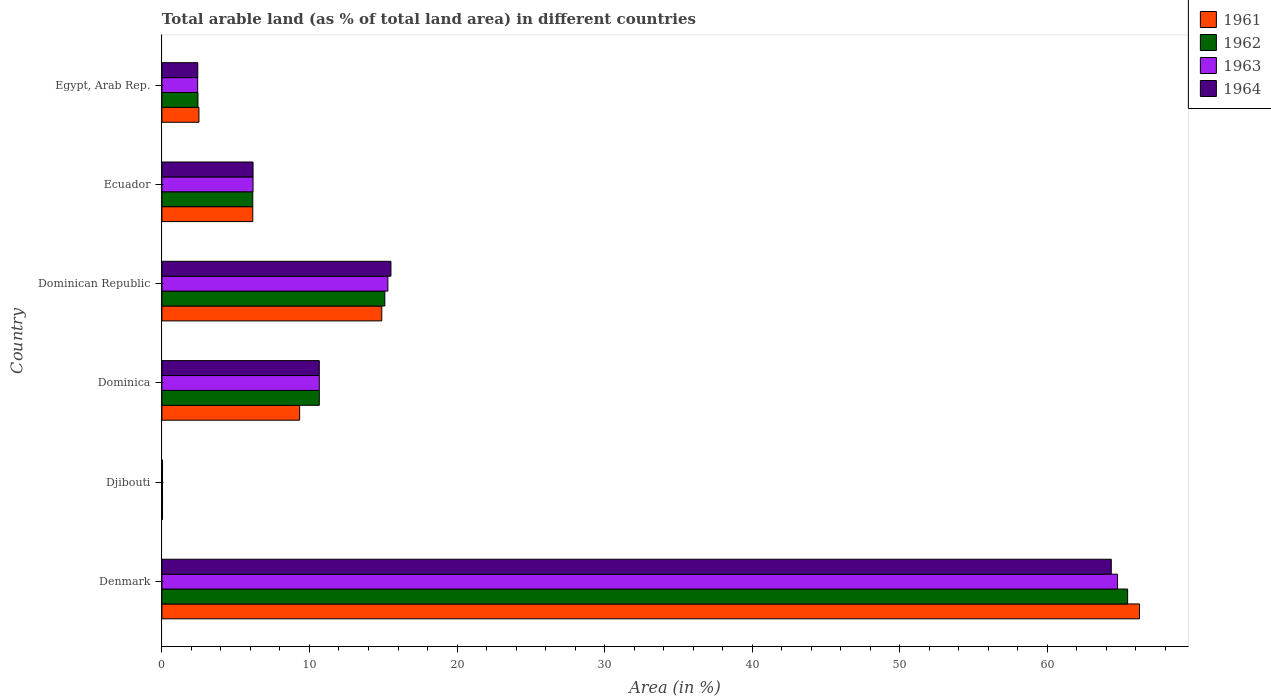How many bars are there on the 2nd tick from the bottom?
Your answer should be compact. 4. What is the label of the 2nd group of bars from the top?
Provide a succinct answer. Ecuador. In how many cases, is the number of bars for a given country not equal to the number of legend labels?
Keep it short and to the point. 0. What is the percentage of arable land in 1963 in Djibouti?
Ensure brevity in your answer.  0.04. Across all countries, what is the maximum percentage of arable land in 1961?
Give a very brief answer. 66.25. Across all countries, what is the minimum percentage of arable land in 1964?
Your answer should be very brief. 0.04. In which country was the percentage of arable land in 1961 minimum?
Your answer should be very brief. Djibouti. What is the total percentage of arable land in 1961 in the graph?
Provide a succinct answer. 99.2. What is the difference between the percentage of arable land in 1964 in Dominican Republic and that in Egypt, Arab Rep.?
Provide a short and direct response. 13.09. What is the difference between the percentage of arable land in 1964 in Dominica and the percentage of arable land in 1963 in Djibouti?
Keep it short and to the point. 10.62. What is the average percentage of arable land in 1964 per country?
Your response must be concise. 16.53. What is the difference between the percentage of arable land in 1962 and percentage of arable land in 1964 in Denmark?
Make the answer very short. 1.11. What is the ratio of the percentage of arable land in 1964 in Dominica to that in Dominican Republic?
Make the answer very short. 0.69. Is the percentage of arable land in 1962 in Djibouti less than that in Egypt, Arab Rep.?
Keep it short and to the point. Yes. What is the difference between the highest and the second highest percentage of arable land in 1962?
Ensure brevity in your answer.  50.34. What is the difference between the highest and the lowest percentage of arable land in 1963?
Keep it short and to the point. 64.72. In how many countries, is the percentage of arable land in 1961 greater than the average percentage of arable land in 1961 taken over all countries?
Provide a succinct answer. 1. Is the sum of the percentage of arable land in 1964 in Dominica and Egypt, Arab Rep. greater than the maximum percentage of arable land in 1961 across all countries?
Your response must be concise. No. What does the 3rd bar from the top in Egypt, Arab Rep. represents?
Provide a succinct answer. 1962. What does the 2nd bar from the bottom in Egypt, Arab Rep. represents?
Provide a short and direct response. 1962. How many countries are there in the graph?
Keep it short and to the point. 6. Are the values on the major ticks of X-axis written in scientific E-notation?
Provide a short and direct response. No. Does the graph contain any zero values?
Your answer should be very brief. No. Does the graph contain grids?
Provide a short and direct response. No. How many legend labels are there?
Offer a terse response. 4. What is the title of the graph?
Your answer should be compact. Total arable land (as % of total land area) in different countries. What is the label or title of the X-axis?
Keep it short and to the point. Area (in %). What is the Area (in %) of 1961 in Denmark?
Your response must be concise. 66.25. What is the Area (in %) of 1962 in Denmark?
Keep it short and to the point. 65.45. What is the Area (in %) of 1963 in Denmark?
Keep it short and to the point. 64.76. What is the Area (in %) of 1964 in Denmark?
Offer a terse response. 64.34. What is the Area (in %) of 1961 in Djibouti?
Give a very brief answer. 0.04. What is the Area (in %) in 1962 in Djibouti?
Keep it short and to the point. 0.04. What is the Area (in %) in 1963 in Djibouti?
Your response must be concise. 0.04. What is the Area (in %) in 1964 in Djibouti?
Your answer should be compact. 0.04. What is the Area (in %) of 1961 in Dominica?
Keep it short and to the point. 9.33. What is the Area (in %) in 1962 in Dominica?
Ensure brevity in your answer.  10.67. What is the Area (in %) of 1963 in Dominica?
Offer a terse response. 10.67. What is the Area (in %) of 1964 in Dominica?
Provide a short and direct response. 10.67. What is the Area (in %) in 1961 in Dominican Republic?
Give a very brief answer. 14.9. What is the Area (in %) of 1962 in Dominican Republic?
Your answer should be very brief. 15.11. What is the Area (in %) in 1963 in Dominican Republic?
Offer a terse response. 15.31. What is the Area (in %) in 1964 in Dominican Republic?
Provide a short and direct response. 15.52. What is the Area (in %) of 1961 in Ecuador?
Your response must be concise. 6.16. What is the Area (in %) of 1962 in Ecuador?
Ensure brevity in your answer.  6.16. What is the Area (in %) of 1963 in Ecuador?
Your answer should be compact. 6.18. What is the Area (in %) of 1964 in Ecuador?
Make the answer very short. 6.18. What is the Area (in %) of 1961 in Egypt, Arab Rep.?
Make the answer very short. 2.51. What is the Area (in %) in 1962 in Egypt, Arab Rep.?
Your answer should be very brief. 2.44. What is the Area (in %) in 1963 in Egypt, Arab Rep.?
Ensure brevity in your answer.  2.42. What is the Area (in %) in 1964 in Egypt, Arab Rep.?
Give a very brief answer. 2.43. Across all countries, what is the maximum Area (in %) in 1961?
Offer a very short reply. 66.25. Across all countries, what is the maximum Area (in %) of 1962?
Make the answer very short. 65.45. Across all countries, what is the maximum Area (in %) in 1963?
Ensure brevity in your answer.  64.76. Across all countries, what is the maximum Area (in %) of 1964?
Make the answer very short. 64.34. Across all countries, what is the minimum Area (in %) in 1961?
Offer a terse response. 0.04. Across all countries, what is the minimum Area (in %) in 1962?
Make the answer very short. 0.04. Across all countries, what is the minimum Area (in %) in 1963?
Make the answer very short. 0.04. Across all countries, what is the minimum Area (in %) in 1964?
Ensure brevity in your answer.  0.04. What is the total Area (in %) in 1961 in the graph?
Provide a succinct answer. 99.2. What is the total Area (in %) of 1962 in the graph?
Your answer should be compact. 99.87. What is the total Area (in %) of 1963 in the graph?
Offer a terse response. 99.39. What is the total Area (in %) in 1964 in the graph?
Make the answer very short. 99.18. What is the difference between the Area (in %) in 1961 in Denmark and that in Djibouti?
Give a very brief answer. 66.21. What is the difference between the Area (in %) of 1962 in Denmark and that in Djibouti?
Your answer should be very brief. 65.4. What is the difference between the Area (in %) of 1963 in Denmark and that in Djibouti?
Make the answer very short. 64.72. What is the difference between the Area (in %) of 1964 in Denmark and that in Djibouti?
Make the answer very short. 64.29. What is the difference between the Area (in %) of 1961 in Denmark and that in Dominica?
Provide a succinct answer. 56.92. What is the difference between the Area (in %) in 1962 in Denmark and that in Dominica?
Your answer should be compact. 54.78. What is the difference between the Area (in %) in 1963 in Denmark and that in Dominica?
Give a very brief answer. 54.1. What is the difference between the Area (in %) in 1964 in Denmark and that in Dominica?
Provide a succinct answer. 53.67. What is the difference between the Area (in %) of 1961 in Denmark and that in Dominican Republic?
Your answer should be compact. 51.35. What is the difference between the Area (in %) of 1962 in Denmark and that in Dominican Republic?
Make the answer very short. 50.34. What is the difference between the Area (in %) in 1963 in Denmark and that in Dominican Republic?
Offer a very short reply. 49.45. What is the difference between the Area (in %) of 1964 in Denmark and that in Dominican Republic?
Your answer should be very brief. 48.82. What is the difference between the Area (in %) in 1961 in Denmark and that in Ecuador?
Your response must be concise. 60.09. What is the difference between the Area (in %) of 1962 in Denmark and that in Ecuador?
Make the answer very short. 59.29. What is the difference between the Area (in %) of 1963 in Denmark and that in Ecuador?
Your answer should be very brief. 58.59. What is the difference between the Area (in %) of 1964 in Denmark and that in Ecuador?
Give a very brief answer. 58.16. What is the difference between the Area (in %) of 1961 in Denmark and that in Egypt, Arab Rep.?
Your response must be concise. 63.74. What is the difference between the Area (in %) of 1962 in Denmark and that in Egypt, Arab Rep.?
Provide a short and direct response. 63. What is the difference between the Area (in %) of 1963 in Denmark and that in Egypt, Arab Rep.?
Give a very brief answer. 62.34. What is the difference between the Area (in %) in 1964 in Denmark and that in Egypt, Arab Rep.?
Offer a terse response. 61.9. What is the difference between the Area (in %) of 1961 in Djibouti and that in Dominica?
Your response must be concise. -9.29. What is the difference between the Area (in %) of 1962 in Djibouti and that in Dominica?
Keep it short and to the point. -10.62. What is the difference between the Area (in %) in 1963 in Djibouti and that in Dominica?
Provide a short and direct response. -10.62. What is the difference between the Area (in %) of 1964 in Djibouti and that in Dominica?
Provide a succinct answer. -10.62. What is the difference between the Area (in %) of 1961 in Djibouti and that in Dominican Republic?
Ensure brevity in your answer.  -14.86. What is the difference between the Area (in %) in 1962 in Djibouti and that in Dominican Republic?
Keep it short and to the point. -15.06. What is the difference between the Area (in %) in 1963 in Djibouti and that in Dominican Republic?
Your answer should be very brief. -15.27. What is the difference between the Area (in %) in 1964 in Djibouti and that in Dominican Republic?
Provide a short and direct response. -15.48. What is the difference between the Area (in %) in 1961 in Djibouti and that in Ecuador?
Your answer should be very brief. -6.12. What is the difference between the Area (in %) of 1962 in Djibouti and that in Ecuador?
Ensure brevity in your answer.  -6.12. What is the difference between the Area (in %) of 1963 in Djibouti and that in Ecuador?
Provide a short and direct response. -6.13. What is the difference between the Area (in %) of 1964 in Djibouti and that in Ecuador?
Keep it short and to the point. -6.13. What is the difference between the Area (in %) of 1961 in Djibouti and that in Egypt, Arab Rep.?
Your response must be concise. -2.47. What is the difference between the Area (in %) of 1962 in Djibouti and that in Egypt, Arab Rep.?
Offer a terse response. -2.4. What is the difference between the Area (in %) in 1963 in Djibouti and that in Egypt, Arab Rep.?
Make the answer very short. -2.38. What is the difference between the Area (in %) in 1964 in Djibouti and that in Egypt, Arab Rep.?
Your response must be concise. -2.39. What is the difference between the Area (in %) in 1961 in Dominica and that in Dominican Republic?
Ensure brevity in your answer.  -5.57. What is the difference between the Area (in %) in 1962 in Dominica and that in Dominican Republic?
Your response must be concise. -4.44. What is the difference between the Area (in %) in 1963 in Dominica and that in Dominican Republic?
Keep it short and to the point. -4.65. What is the difference between the Area (in %) in 1964 in Dominica and that in Dominican Republic?
Ensure brevity in your answer.  -4.85. What is the difference between the Area (in %) of 1961 in Dominica and that in Ecuador?
Give a very brief answer. 3.17. What is the difference between the Area (in %) of 1962 in Dominica and that in Ecuador?
Provide a succinct answer. 4.51. What is the difference between the Area (in %) in 1963 in Dominica and that in Ecuador?
Your answer should be compact. 4.49. What is the difference between the Area (in %) of 1964 in Dominica and that in Ecuador?
Your answer should be very brief. 4.49. What is the difference between the Area (in %) in 1961 in Dominica and that in Egypt, Arab Rep.?
Ensure brevity in your answer.  6.82. What is the difference between the Area (in %) of 1962 in Dominica and that in Egypt, Arab Rep.?
Your response must be concise. 8.22. What is the difference between the Area (in %) in 1963 in Dominica and that in Egypt, Arab Rep.?
Keep it short and to the point. 8.24. What is the difference between the Area (in %) in 1964 in Dominica and that in Egypt, Arab Rep.?
Ensure brevity in your answer.  8.23. What is the difference between the Area (in %) in 1961 in Dominican Republic and that in Ecuador?
Your answer should be compact. 8.74. What is the difference between the Area (in %) in 1962 in Dominican Republic and that in Ecuador?
Provide a short and direct response. 8.95. What is the difference between the Area (in %) in 1963 in Dominican Republic and that in Ecuador?
Provide a short and direct response. 9.14. What is the difference between the Area (in %) of 1964 in Dominican Republic and that in Ecuador?
Offer a terse response. 9.34. What is the difference between the Area (in %) of 1961 in Dominican Republic and that in Egypt, Arab Rep.?
Make the answer very short. 12.39. What is the difference between the Area (in %) in 1962 in Dominican Republic and that in Egypt, Arab Rep.?
Ensure brevity in your answer.  12.66. What is the difference between the Area (in %) of 1963 in Dominican Republic and that in Egypt, Arab Rep.?
Provide a short and direct response. 12.89. What is the difference between the Area (in %) in 1964 in Dominican Republic and that in Egypt, Arab Rep.?
Your answer should be compact. 13.09. What is the difference between the Area (in %) of 1961 in Ecuador and that in Egypt, Arab Rep.?
Offer a terse response. 3.65. What is the difference between the Area (in %) of 1962 in Ecuador and that in Egypt, Arab Rep.?
Make the answer very short. 3.71. What is the difference between the Area (in %) of 1963 in Ecuador and that in Egypt, Arab Rep.?
Keep it short and to the point. 3.75. What is the difference between the Area (in %) in 1964 in Ecuador and that in Egypt, Arab Rep.?
Provide a short and direct response. 3.74. What is the difference between the Area (in %) in 1961 in Denmark and the Area (in %) in 1962 in Djibouti?
Give a very brief answer. 66.21. What is the difference between the Area (in %) in 1961 in Denmark and the Area (in %) in 1963 in Djibouti?
Provide a succinct answer. 66.21. What is the difference between the Area (in %) in 1961 in Denmark and the Area (in %) in 1964 in Djibouti?
Provide a succinct answer. 66.21. What is the difference between the Area (in %) of 1962 in Denmark and the Area (in %) of 1963 in Djibouti?
Ensure brevity in your answer.  65.4. What is the difference between the Area (in %) of 1962 in Denmark and the Area (in %) of 1964 in Djibouti?
Keep it short and to the point. 65.4. What is the difference between the Area (in %) of 1963 in Denmark and the Area (in %) of 1964 in Djibouti?
Keep it short and to the point. 64.72. What is the difference between the Area (in %) in 1961 in Denmark and the Area (in %) in 1962 in Dominica?
Provide a short and direct response. 55.58. What is the difference between the Area (in %) of 1961 in Denmark and the Area (in %) of 1963 in Dominica?
Provide a short and direct response. 55.58. What is the difference between the Area (in %) of 1961 in Denmark and the Area (in %) of 1964 in Dominica?
Keep it short and to the point. 55.58. What is the difference between the Area (in %) in 1962 in Denmark and the Area (in %) in 1963 in Dominica?
Your answer should be compact. 54.78. What is the difference between the Area (in %) in 1962 in Denmark and the Area (in %) in 1964 in Dominica?
Your response must be concise. 54.78. What is the difference between the Area (in %) in 1963 in Denmark and the Area (in %) in 1964 in Dominica?
Provide a short and direct response. 54.1. What is the difference between the Area (in %) of 1961 in Denmark and the Area (in %) of 1962 in Dominican Republic?
Keep it short and to the point. 51.14. What is the difference between the Area (in %) of 1961 in Denmark and the Area (in %) of 1963 in Dominican Republic?
Offer a very short reply. 50.94. What is the difference between the Area (in %) in 1961 in Denmark and the Area (in %) in 1964 in Dominican Republic?
Your answer should be very brief. 50.73. What is the difference between the Area (in %) of 1962 in Denmark and the Area (in %) of 1963 in Dominican Republic?
Provide a succinct answer. 50.13. What is the difference between the Area (in %) of 1962 in Denmark and the Area (in %) of 1964 in Dominican Republic?
Provide a short and direct response. 49.93. What is the difference between the Area (in %) of 1963 in Denmark and the Area (in %) of 1964 in Dominican Republic?
Offer a terse response. 49.24. What is the difference between the Area (in %) of 1961 in Denmark and the Area (in %) of 1962 in Ecuador?
Provide a short and direct response. 60.09. What is the difference between the Area (in %) of 1961 in Denmark and the Area (in %) of 1963 in Ecuador?
Provide a short and direct response. 60.07. What is the difference between the Area (in %) in 1961 in Denmark and the Area (in %) in 1964 in Ecuador?
Your answer should be very brief. 60.07. What is the difference between the Area (in %) in 1962 in Denmark and the Area (in %) in 1963 in Ecuador?
Keep it short and to the point. 59.27. What is the difference between the Area (in %) in 1962 in Denmark and the Area (in %) in 1964 in Ecuador?
Offer a terse response. 59.27. What is the difference between the Area (in %) of 1963 in Denmark and the Area (in %) of 1964 in Ecuador?
Your answer should be compact. 58.59. What is the difference between the Area (in %) of 1961 in Denmark and the Area (in %) of 1962 in Egypt, Arab Rep.?
Make the answer very short. 63.81. What is the difference between the Area (in %) of 1961 in Denmark and the Area (in %) of 1963 in Egypt, Arab Rep.?
Offer a terse response. 63.83. What is the difference between the Area (in %) of 1961 in Denmark and the Area (in %) of 1964 in Egypt, Arab Rep.?
Give a very brief answer. 63.82. What is the difference between the Area (in %) of 1962 in Denmark and the Area (in %) of 1963 in Egypt, Arab Rep.?
Provide a short and direct response. 63.02. What is the difference between the Area (in %) in 1962 in Denmark and the Area (in %) in 1964 in Egypt, Arab Rep.?
Offer a very short reply. 63.01. What is the difference between the Area (in %) in 1963 in Denmark and the Area (in %) in 1964 in Egypt, Arab Rep.?
Give a very brief answer. 62.33. What is the difference between the Area (in %) in 1961 in Djibouti and the Area (in %) in 1962 in Dominica?
Your answer should be very brief. -10.62. What is the difference between the Area (in %) of 1961 in Djibouti and the Area (in %) of 1963 in Dominica?
Your answer should be compact. -10.62. What is the difference between the Area (in %) in 1961 in Djibouti and the Area (in %) in 1964 in Dominica?
Provide a short and direct response. -10.62. What is the difference between the Area (in %) in 1962 in Djibouti and the Area (in %) in 1963 in Dominica?
Your response must be concise. -10.62. What is the difference between the Area (in %) of 1962 in Djibouti and the Area (in %) of 1964 in Dominica?
Make the answer very short. -10.62. What is the difference between the Area (in %) in 1963 in Djibouti and the Area (in %) in 1964 in Dominica?
Keep it short and to the point. -10.62. What is the difference between the Area (in %) of 1961 in Djibouti and the Area (in %) of 1962 in Dominican Republic?
Provide a short and direct response. -15.06. What is the difference between the Area (in %) of 1961 in Djibouti and the Area (in %) of 1963 in Dominican Republic?
Provide a succinct answer. -15.27. What is the difference between the Area (in %) of 1961 in Djibouti and the Area (in %) of 1964 in Dominican Republic?
Provide a short and direct response. -15.48. What is the difference between the Area (in %) of 1962 in Djibouti and the Area (in %) of 1963 in Dominican Republic?
Keep it short and to the point. -15.27. What is the difference between the Area (in %) in 1962 in Djibouti and the Area (in %) in 1964 in Dominican Republic?
Give a very brief answer. -15.48. What is the difference between the Area (in %) of 1963 in Djibouti and the Area (in %) of 1964 in Dominican Republic?
Provide a succinct answer. -15.48. What is the difference between the Area (in %) of 1961 in Djibouti and the Area (in %) of 1962 in Ecuador?
Provide a short and direct response. -6.12. What is the difference between the Area (in %) in 1961 in Djibouti and the Area (in %) in 1963 in Ecuador?
Keep it short and to the point. -6.13. What is the difference between the Area (in %) in 1961 in Djibouti and the Area (in %) in 1964 in Ecuador?
Give a very brief answer. -6.13. What is the difference between the Area (in %) in 1962 in Djibouti and the Area (in %) in 1963 in Ecuador?
Offer a terse response. -6.13. What is the difference between the Area (in %) in 1962 in Djibouti and the Area (in %) in 1964 in Ecuador?
Offer a terse response. -6.13. What is the difference between the Area (in %) in 1963 in Djibouti and the Area (in %) in 1964 in Ecuador?
Provide a succinct answer. -6.13. What is the difference between the Area (in %) in 1961 in Djibouti and the Area (in %) in 1962 in Egypt, Arab Rep.?
Keep it short and to the point. -2.4. What is the difference between the Area (in %) of 1961 in Djibouti and the Area (in %) of 1963 in Egypt, Arab Rep.?
Give a very brief answer. -2.38. What is the difference between the Area (in %) of 1961 in Djibouti and the Area (in %) of 1964 in Egypt, Arab Rep.?
Offer a very short reply. -2.39. What is the difference between the Area (in %) in 1962 in Djibouti and the Area (in %) in 1963 in Egypt, Arab Rep.?
Offer a very short reply. -2.38. What is the difference between the Area (in %) in 1962 in Djibouti and the Area (in %) in 1964 in Egypt, Arab Rep.?
Make the answer very short. -2.39. What is the difference between the Area (in %) in 1963 in Djibouti and the Area (in %) in 1964 in Egypt, Arab Rep.?
Provide a short and direct response. -2.39. What is the difference between the Area (in %) of 1961 in Dominica and the Area (in %) of 1962 in Dominican Republic?
Offer a very short reply. -5.77. What is the difference between the Area (in %) of 1961 in Dominica and the Area (in %) of 1963 in Dominican Republic?
Your answer should be compact. -5.98. What is the difference between the Area (in %) of 1961 in Dominica and the Area (in %) of 1964 in Dominican Republic?
Your answer should be compact. -6.19. What is the difference between the Area (in %) in 1962 in Dominica and the Area (in %) in 1963 in Dominican Republic?
Your response must be concise. -4.65. What is the difference between the Area (in %) in 1962 in Dominica and the Area (in %) in 1964 in Dominican Republic?
Your answer should be compact. -4.85. What is the difference between the Area (in %) in 1963 in Dominica and the Area (in %) in 1964 in Dominican Republic?
Provide a succinct answer. -4.85. What is the difference between the Area (in %) of 1961 in Dominica and the Area (in %) of 1962 in Ecuador?
Ensure brevity in your answer.  3.17. What is the difference between the Area (in %) of 1961 in Dominica and the Area (in %) of 1963 in Ecuador?
Offer a terse response. 3.16. What is the difference between the Area (in %) of 1961 in Dominica and the Area (in %) of 1964 in Ecuador?
Your answer should be very brief. 3.16. What is the difference between the Area (in %) of 1962 in Dominica and the Area (in %) of 1963 in Ecuador?
Give a very brief answer. 4.49. What is the difference between the Area (in %) of 1962 in Dominica and the Area (in %) of 1964 in Ecuador?
Offer a very short reply. 4.49. What is the difference between the Area (in %) in 1963 in Dominica and the Area (in %) in 1964 in Ecuador?
Your answer should be compact. 4.49. What is the difference between the Area (in %) in 1961 in Dominica and the Area (in %) in 1962 in Egypt, Arab Rep.?
Your answer should be compact. 6.89. What is the difference between the Area (in %) in 1961 in Dominica and the Area (in %) in 1963 in Egypt, Arab Rep.?
Your answer should be compact. 6.91. What is the difference between the Area (in %) in 1961 in Dominica and the Area (in %) in 1964 in Egypt, Arab Rep.?
Your response must be concise. 6.9. What is the difference between the Area (in %) of 1962 in Dominica and the Area (in %) of 1963 in Egypt, Arab Rep.?
Offer a terse response. 8.24. What is the difference between the Area (in %) of 1962 in Dominica and the Area (in %) of 1964 in Egypt, Arab Rep.?
Make the answer very short. 8.23. What is the difference between the Area (in %) in 1963 in Dominica and the Area (in %) in 1964 in Egypt, Arab Rep.?
Give a very brief answer. 8.23. What is the difference between the Area (in %) of 1961 in Dominican Republic and the Area (in %) of 1962 in Ecuador?
Offer a terse response. 8.74. What is the difference between the Area (in %) in 1961 in Dominican Republic and the Area (in %) in 1963 in Ecuador?
Offer a very short reply. 8.72. What is the difference between the Area (in %) of 1961 in Dominican Republic and the Area (in %) of 1964 in Ecuador?
Offer a very short reply. 8.72. What is the difference between the Area (in %) of 1962 in Dominican Republic and the Area (in %) of 1963 in Ecuador?
Your answer should be compact. 8.93. What is the difference between the Area (in %) in 1962 in Dominican Republic and the Area (in %) in 1964 in Ecuador?
Your response must be concise. 8.93. What is the difference between the Area (in %) of 1963 in Dominican Republic and the Area (in %) of 1964 in Ecuador?
Your response must be concise. 9.14. What is the difference between the Area (in %) of 1961 in Dominican Republic and the Area (in %) of 1962 in Egypt, Arab Rep.?
Ensure brevity in your answer.  12.46. What is the difference between the Area (in %) in 1961 in Dominican Republic and the Area (in %) in 1963 in Egypt, Arab Rep.?
Offer a very short reply. 12.48. What is the difference between the Area (in %) of 1961 in Dominican Republic and the Area (in %) of 1964 in Egypt, Arab Rep.?
Your answer should be compact. 12.47. What is the difference between the Area (in %) in 1962 in Dominican Republic and the Area (in %) in 1963 in Egypt, Arab Rep.?
Give a very brief answer. 12.68. What is the difference between the Area (in %) in 1962 in Dominican Republic and the Area (in %) in 1964 in Egypt, Arab Rep.?
Keep it short and to the point. 12.67. What is the difference between the Area (in %) of 1963 in Dominican Republic and the Area (in %) of 1964 in Egypt, Arab Rep.?
Offer a very short reply. 12.88. What is the difference between the Area (in %) of 1961 in Ecuador and the Area (in %) of 1962 in Egypt, Arab Rep.?
Offer a very short reply. 3.71. What is the difference between the Area (in %) of 1961 in Ecuador and the Area (in %) of 1963 in Egypt, Arab Rep.?
Offer a very short reply. 3.73. What is the difference between the Area (in %) in 1961 in Ecuador and the Area (in %) in 1964 in Egypt, Arab Rep.?
Your answer should be compact. 3.73. What is the difference between the Area (in %) in 1962 in Ecuador and the Area (in %) in 1963 in Egypt, Arab Rep.?
Provide a succinct answer. 3.73. What is the difference between the Area (in %) of 1962 in Ecuador and the Area (in %) of 1964 in Egypt, Arab Rep.?
Offer a terse response. 3.73. What is the difference between the Area (in %) in 1963 in Ecuador and the Area (in %) in 1964 in Egypt, Arab Rep.?
Your answer should be compact. 3.74. What is the average Area (in %) of 1961 per country?
Offer a very short reply. 16.53. What is the average Area (in %) of 1962 per country?
Your answer should be very brief. 16.64. What is the average Area (in %) of 1963 per country?
Your answer should be compact. 16.56. What is the average Area (in %) in 1964 per country?
Your response must be concise. 16.53. What is the difference between the Area (in %) in 1961 and Area (in %) in 1962 in Denmark?
Keep it short and to the point. 0.8. What is the difference between the Area (in %) of 1961 and Area (in %) of 1963 in Denmark?
Provide a succinct answer. 1.49. What is the difference between the Area (in %) in 1961 and Area (in %) in 1964 in Denmark?
Offer a very short reply. 1.91. What is the difference between the Area (in %) in 1962 and Area (in %) in 1963 in Denmark?
Offer a very short reply. 0.68. What is the difference between the Area (in %) of 1962 and Area (in %) of 1964 in Denmark?
Provide a succinct answer. 1.11. What is the difference between the Area (in %) of 1963 and Area (in %) of 1964 in Denmark?
Your response must be concise. 0.42. What is the difference between the Area (in %) of 1961 and Area (in %) of 1962 in Djibouti?
Your answer should be very brief. 0. What is the difference between the Area (in %) in 1961 and Area (in %) in 1963 in Djibouti?
Keep it short and to the point. 0. What is the difference between the Area (in %) in 1961 and Area (in %) in 1964 in Djibouti?
Your answer should be compact. 0. What is the difference between the Area (in %) in 1962 and Area (in %) in 1963 in Djibouti?
Give a very brief answer. 0. What is the difference between the Area (in %) of 1962 and Area (in %) of 1964 in Djibouti?
Provide a short and direct response. 0. What is the difference between the Area (in %) in 1961 and Area (in %) in 1962 in Dominica?
Provide a short and direct response. -1.33. What is the difference between the Area (in %) in 1961 and Area (in %) in 1963 in Dominica?
Ensure brevity in your answer.  -1.33. What is the difference between the Area (in %) in 1961 and Area (in %) in 1964 in Dominica?
Make the answer very short. -1.33. What is the difference between the Area (in %) in 1962 and Area (in %) in 1964 in Dominica?
Give a very brief answer. 0. What is the difference between the Area (in %) of 1961 and Area (in %) of 1962 in Dominican Republic?
Provide a short and direct response. -0.21. What is the difference between the Area (in %) in 1961 and Area (in %) in 1963 in Dominican Republic?
Offer a very short reply. -0.41. What is the difference between the Area (in %) in 1961 and Area (in %) in 1964 in Dominican Republic?
Ensure brevity in your answer.  -0.62. What is the difference between the Area (in %) in 1962 and Area (in %) in 1963 in Dominican Republic?
Ensure brevity in your answer.  -0.21. What is the difference between the Area (in %) of 1962 and Area (in %) of 1964 in Dominican Republic?
Your answer should be compact. -0.41. What is the difference between the Area (in %) in 1963 and Area (in %) in 1964 in Dominican Republic?
Offer a terse response. -0.21. What is the difference between the Area (in %) in 1961 and Area (in %) in 1963 in Ecuador?
Make the answer very short. -0.02. What is the difference between the Area (in %) in 1961 and Area (in %) in 1964 in Ecuador?
Your answer should be very brief. -0.02. What is the difference between the Area (in %) of 1962 and Area (in %) of 1963 in Ecuador?
Your response must be concise. -0.02. What is the difference between the Area (in %) of 1962 and Area (in %) of 1964 in Ecuador?
Keep it short and to the point. -0.02. What is the difference between the Area (in %) of 1963 and Area (in %) of 1964 in Ecuador?
Offer a very short reply. 0. What is the difference between the Area (in %) in 1961 and Area (in %) in 1962 in Egypt, Arab Rep.?
Ensure brevity in your answer.  0.07. What is the difference between the Area (in %) in 1961 and Area (in %) in 1963 in Egypt, Arab Rep.?
Provide a succinct answer. 0.09. What is the difference between the Area (in %) of 1961 and Area (in %) of 1964 in Egypt, Arab Rep.?
Offer a terse response. 0.08. What is the difference between the Area (in %) of 1962 and Area (in %) of 1963 in Egypt, Arab Rep.?
Provide a short and direct response. 0.02. What is the difference between the Area (in %) in 1962 and Area (in %) in 1964 in Egypt, Arab Rep.?
Your answer should be compact. 0.01. What is the difference between the Area (in %) in 1963 and Area (in %) in 1964 in Egypt, Arab Rep.?
Your answer should be compact. -0.01. What is the ratio of the Area (in %) of 1961 in Denmark to that in Djibouti?
Ensure brevity in your answer.  1535.67. What is the ratio of the Area (in %) in 1962 in Denmark to that in Djibouti?
Offer a very short reply. 1517.07. What is the ratio of the Area (in %) of 1963 in Denmark to that in Djibouti?
Provide a short and direct response. 1501.2. What is the ratio of the Area (in %) in 1964 in Denmark to that in Djibouti?
Ensure brevity in your answer.  1491.35. What is the ratio of the Area (in %) in 1961 in Denmark to that in Dominica?
Give a very brief answer. 7.1. What is the ratio of the Area (in %) of 1962 in Denmark to that in Dominica?
Your answer should be compact. 6.14. What is the ratio of the Area (in %) of 1963 in Denmark to that in Dominica?
Ensure brevity in your answer.  6.07. What is the ratio of the Area (in %) in 1964 in Denmark to that in Dominica?
Give a very brief answer. 6.03. What is the ratio of the Area (in %) of 1961 in Denmark to that in Dominican Republic?
Offer a very short reply. 4.45. What is the ratio of the Area (in %) of 1962 in Denmark to that in Dominican Republic?
Ensure brevity in your answer.  4.33. What is the ratio of the Area (in %) in 1963 in Denmark to that in Dominican Republic?
Ensure brevity in your answer.  4.23. What is the ratio of the Area (in %) in 1964 in Denmark to that in Dominican Republic?
Ensure brevity in your answer.  4.15. What is the ratio of the Area (in %) in 1961 in Denmark to that in Ecuador?
Provide a short and direct response. 10.76. What is the ratio of the Area (in %) of 1962 in Denmark to that in Ecuador?
Provide a succinct answer. 10.63. What is the ratio of the Area (in %) of 1963 in Denmark to that in Ecuador?
Keep it short and to the point. 10.48. What is the ratio of the Area (in %) in 1964 in Denmark to that in Ecuador?
Offer a terse response. 10.42. What is the ratio of the Area (in %) in 1961 in Denmark to that in Egypt, Arab Rep.?
Offer a very short reply. 26.39. What is the ratio of the Area (in %) of 1962 in Denmark to that in Egypt, Arab Rep.?
Your response must be concise. 26.78. What is the ratio of the Area (in %) in 1963 in Denmark to that in Egypt, Arab Rep.?
Your answer should be very brief. 26.72. What is the ratio of the Area (in %) of 1964 in Denmark to that in Egypt, Arab Rep.?
Ensure brevity in your answer.  26.44. What is the ratio of the Area (in %) in 1961 in Djibouti to that in Dominica?
Your response must be concise. 0. What is the ratio of the Area (in %) of 1962 in Djibouti to that in Dominica?
Your answer should be very brief. 0. What is the ratio of the Area (in %) of 1963 in Djibouti to that in Dominica?
Your answer should be compact. 0. What is the ratio of the Area (in %) in 1964 in Djibouti to that in Dominica?
Make the answer very short. 0. What is the ratio of the Area (in %) in 1961 in Djibouti to that in Dominican Republic?
Your answer should be very brief. 0. What is the ratio of the Area (in %) in 1962 in Djibouti to that in Dominican Republic?
Offer a terse response. 0. What is the ratio of the Area (in %) in 1963 in Djibouti to that in Dominican Republic?
Offer a terse response. 0. What is the ratio of the Area (in %) of 1964 in Djibouti to that in Dominican Republic?
Offer a very short reply. 0. What is the ratio of the Area (in %) of 1961 in Djibouti to that in Ecuador?
Provide a succinct answer. 0.01. What is the ratio of the Area (in %) of 1962 in Djibouti to that in Ecuador?
Provide a succinct answer. 0.01. What is the ratio of the Area (in %) of 1963 in Djibouti to that in Ecuador?
Provide a short and direct response. 0.01. What is the ratio of the Area (in %) in 1964 in Djibouti to that in Ecuador?
Give a very brief answer. 0.01. What is the ratio of the Area (in %) in 1961 in Djibouti to that in Egypt, Arab Rep.?
Offer a very short reply. 0.02. What is the ratio of the Area (in %) of 1962 in Djibouti to that in Egypt, Arab Rep.?
Provide a succinct answer. 0.02. What is the ratio of the Area (in %) of 1963 in Djibouti to that in Egypt, Arab Rep.?
Offer a terse response. 0.02. What is the ratio of the Area (in %) of 1964 in Djibouti to that in Egypt, Arab Rep.?
Your answer should be very brief. 0.02. What is the ratio of the Area (in %) of 1961 in Dominica to that in Dominican Republic?
Offer a terse response. 0.63. What is the ratio of the Area (in %) in 1962 in Dominica to that in Dominican Republic?
Keep it short and to the point. 0.71. What is the ratio of the Area (in %) of 1963 in Dominica to that in Dominican Republic?
Keep it short and to the point. 0.7. What is the ratio of the Area (in %) of 1964 in Dominica to that in Dominican Republic?
Ensure brevity in your answer.  0.69. What is the ratio of the Area (in %) in 1961 in Dominica to that in Ecuador?
Your response must be concise. 1.52. What is the ratio of the Area (in %) in 1962 in Dominica to that in Ecuador?
Offer a very short reply. 1.73. What is the ratio of the Area (in %) in 1963 in Dominica to that in Ecuador?
Provide a succinct answer. 1.73. What is the ratio of the Area (in %) in 1964 in Dominica to that in Ecuador?
Offer a very short reply. 1.73. What is the ratio of the Area (in %) in 1961 in Dominica to that in Egypt, Arab Rep.?
Your answer should be compact. 3.72. What is the ratio of the Area (in %) in 1962 in Dominica to that in Egypt, Arab Rep.?
Provide a succinct answer. 4.36. What is the ratio of the Area (in %) of 1963 in Dominica to that in Egypt, Arab Rep.?
Your answer should be compact. 4.4. What is the ratio of the Area (in %) of 1964 in Dominica to that in Egypt, Arab Rep.?
Make the answer very short. 4.38. What is the ratio of the Area (in %) of 1961 in Dominican Republic to that in Ecuador?
Make the answer very short. 2.42. What is the ratio of the Area (in %) in 1962 in Dominican Republic to that in Ecuador?
Provide a succinct answer. 2.45. What is the ratio of the Area (in %) of 1963 in Dominican Republic to that in Ecuador?
Make the answer very short. 2.48. What is the ratio of the Area (in %) of 1964 in Dominican Republic to that in Ecuador?
Provide a short and direct response. 2.51. What is the ratio of the Area (in %) in 1961 in Dominican Republic to that in Egypt, Arab Rep.?
Provide a succinct answer. 5.94. What is the ratio of the Area (in %) of 1962 in Dominican Republic to that in Egypt, Arab Rep.?
Your answer should be compact. 6.18. What is the ratio of the Area (in %) in 1963 in Dominican Republic to that in Egypt, Arab Rep.?
Provide a short and direct response. 6.32. What is the ratio of the Area (in %) in 1964 in Dominican Republic to that in Egypt, Arab Rep.?
Offer a very short reply. 6.38. What is the ratio of the Area (in %) in 1961 in Ecuador to that in Egypt, Arab Rep.?
Make the answer very short. 2.45. What is the ratio of the Area (in %) of 1962 in Ecuador to that in Egypt, Arab Rep.?
Your response must be concise. 2.52. What is the ratio of the Area (in %) of 1963 in Ecuador to that in Egypt, Arab Rep.?
Your response must be concise. 2.55. What is the ratio of the Area (in %) of 1964 in Ecuador to that in Egypt, Arab Rep.?
Ensure brevity in your answer.  2.54. What is the difference between the highest and the second highest Area (in %) of 1961?
Give a very brief answer. 51.35. What is the difference between the highest and the second highest Area (in %) of 1962?
Your response must be concise. 50.34. What is the difference between the highest and the second highest Area (in %) of 1963?
Provide a short and direct response. 49.45. What is the difference between the highest and the second highest Area (in %) in 1964?
Give a very brief answer. 48.82. What is the difference between the highest and the lowest Area (in %) of 1961?
Offer a terse response. 66.21. What is the difference between the highest and the lowest Area (in %) in 1962?
Offer a terse response. 65.4. What is the difference between the highest and the lowest Area (in %) in 1963?
Provide a short and direct response. 64.72. What is the difference between the highest and the lowest Area (in %) in 1964?
Ensure brevity in your answer.  64.29. 